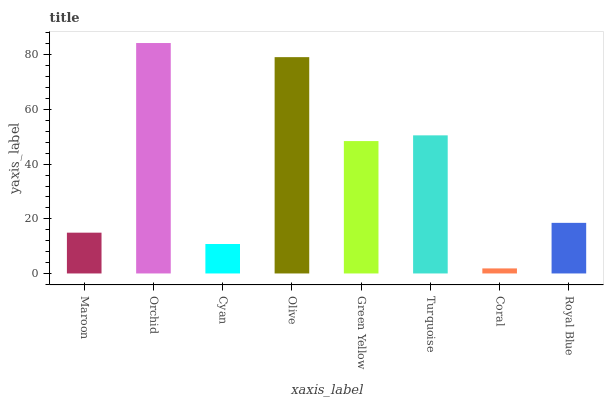Is Coral the minimum?
Answer yes or no. Yes. Is Orchid the maximum?
Answer yes or no. Yes. Is Cyan the minimum?
Answer yes or no. No. Is Cyan the maximum?
Answer yes or no. No. Is Orchid greater than Cyan?
Answer yes or no. Yes. Is Cyan less than Orchid?
Answer yes or no. Yes. Is Cyan greater than Orchid?
Answer yes or no. No. Is Orchid less than Cyan?
Answer yes or no. No. Is Green Yellow the high median?
Answer yes or no. Yes. Is Royal Blue the low median?
Answer yes or no. Yes. Is Coral the high median?
Answer yes or no. No. Is Coral the low median?
Answer yes or no. No. 